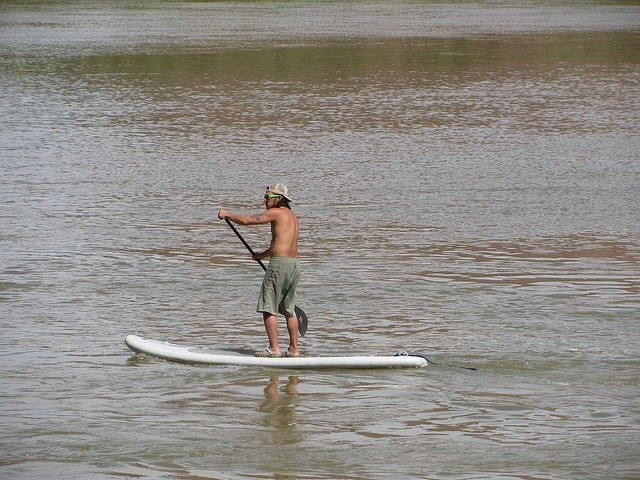Describe the objects in this image and their specific colors. I can see people in darkgreen, gray, darkgray, and black tones and surfboard in darkgreen, lightgray, darkgray, gray, and black tones in this image. 